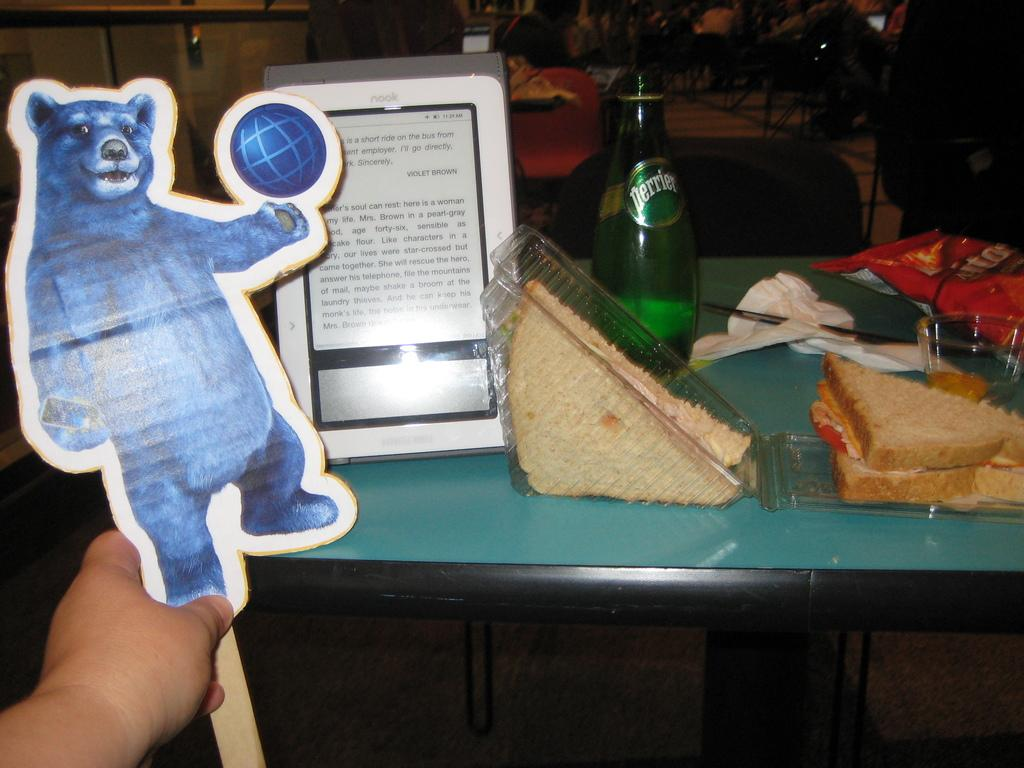<image>
Share a concise interpretation of the image provided. A nook sits on a table next to a bottle of Perrier water and a sandwich. 